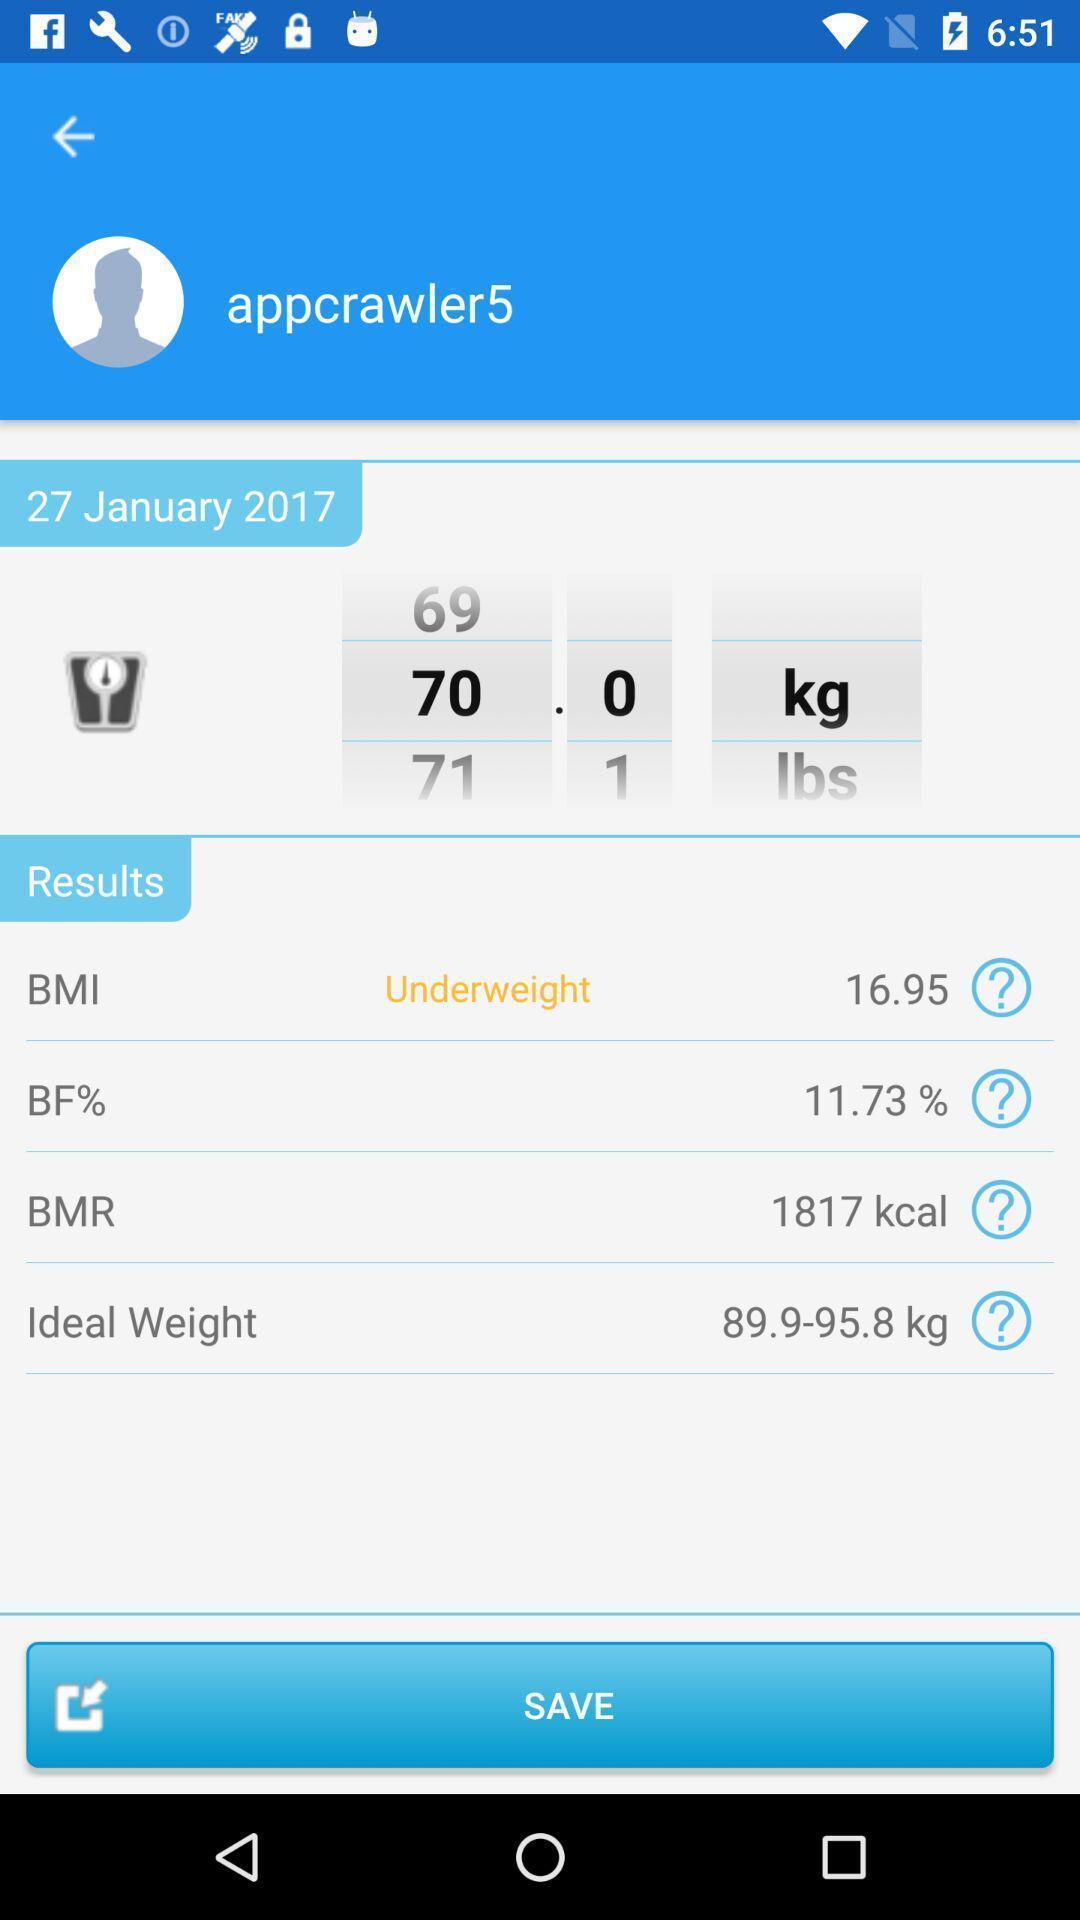Describe the content in this image. Page displaying the contact info. 